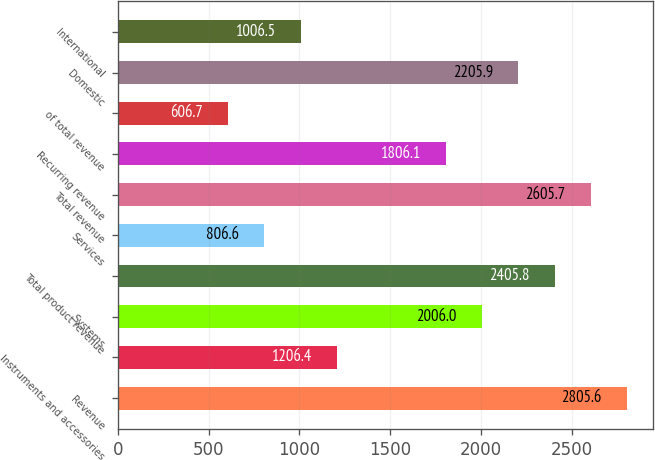Convert chart. <chart><loc_0><loc_0><loc_500><loc_500><bar_chart><fcel>Revenue<fcel>Instruments and accessories<fcel>Systems<fcel>Total product revenue<fcel>Services<fcel>Total revenue<fcel>Recurring revenue<fcel>of total revenue<fcel>Domestic<fcel>International<nl><fcel>2805.6<fcel>1206.4<fcel>2006<fcel>2405.8<fcel>806.6<fcel>2605.7<fcel>1806.1<fcel>606.7<fcel>2205.9<fcel>1006.5<nl></chart> 